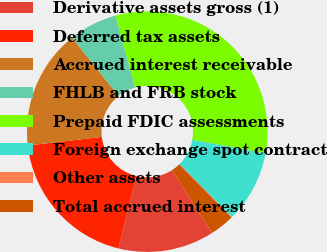<chart> <loc_0><loc_0><loc_500><loc_500><pie_chart><fcel>Derivative assets gross (1)<fcel>Deferred tax assets<fcel>Accrued interest receivable<fcel>FHLB and FRB stock<fcel>Prepaid FDIC assessments<fcel>Foreign exchange spot contract<fcel>Other assets<fcel>Total accrued interest<nl><fcel>12.9%<fcel>19.31%<fcel>16.1%<fcel>6.49%<fcel>32.12%<fcel>9.7%<fcel>0.08%<fcel>3.29%<nl></chart> 